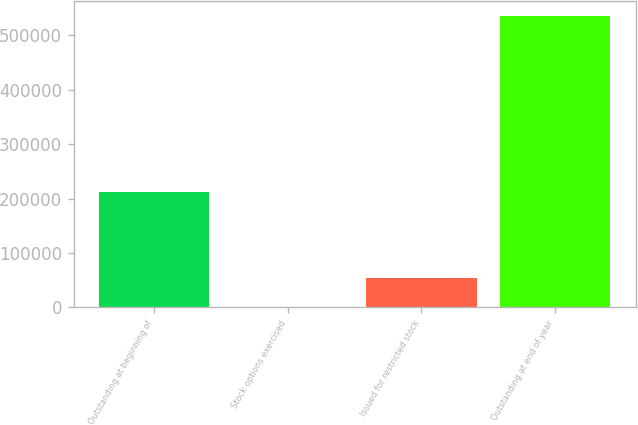Convert chart. <chart><loc_0><loc_0><loc_500><loc_500><bar_chart><fcel>Outstanding at beginning of<fcel>Stock options exercised<fcel>Issued for restricted stock<fcel>Outstanding at end of year<nl><fcel>211359<fcel>133<fcel>53717.3<fcel>535976<nl></chart> 